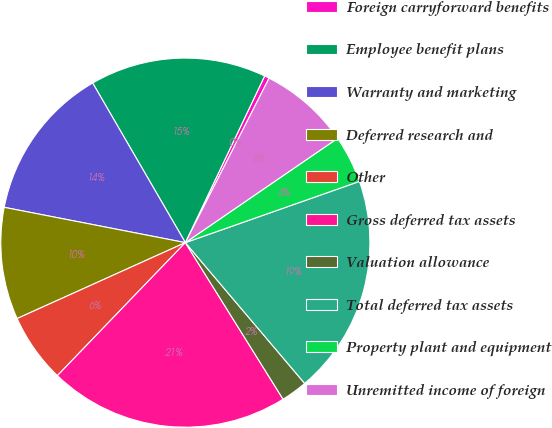<chart> <loc_0><loc_0><loc_500><loc_500><pie_chart><fcel>Foreign carryforward benefits<fcel>Employee benefit plans<fcel>Warranty and marketing<fcel>Deferred research and<fcel>Other<fcel>Gross deferred tax assets<fcel>Valuation allowance<fcel>Total deferred tax assets<fcel>Property plant and equipment<fcel>Unremitted income of foreign<nl><fcel>0.43%<fcel>15.44%<fcel>13.56%<fcel>9.81%<fcel>6.06%<fcel>21.07%<fcel>2.31%<fcel>19.19%<fcel>4.18%<fcel>7.94%<nl></chart> 